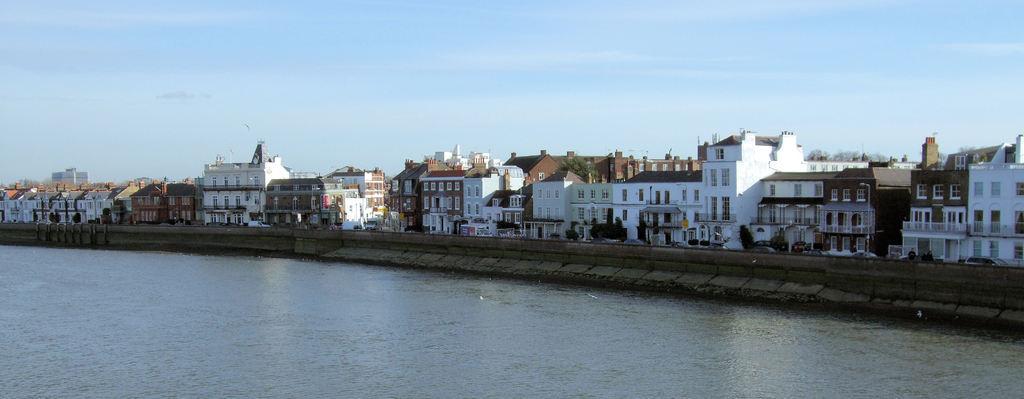Could you give a brief overview of what you see in this image? In the foreground of this image, there is water. In the middle, there are buildings and vehicles. At the top, there is the sky and the cloud. 